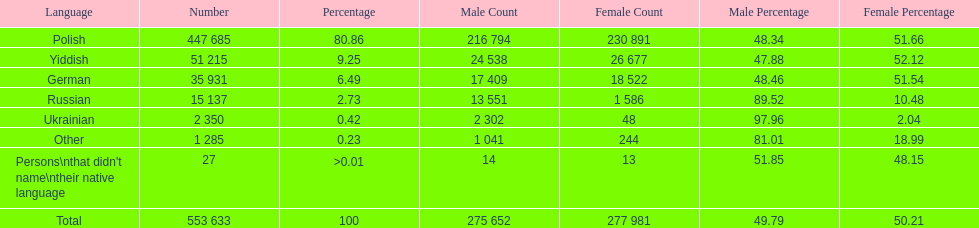Which is the least spoken language? Ukrainian. 